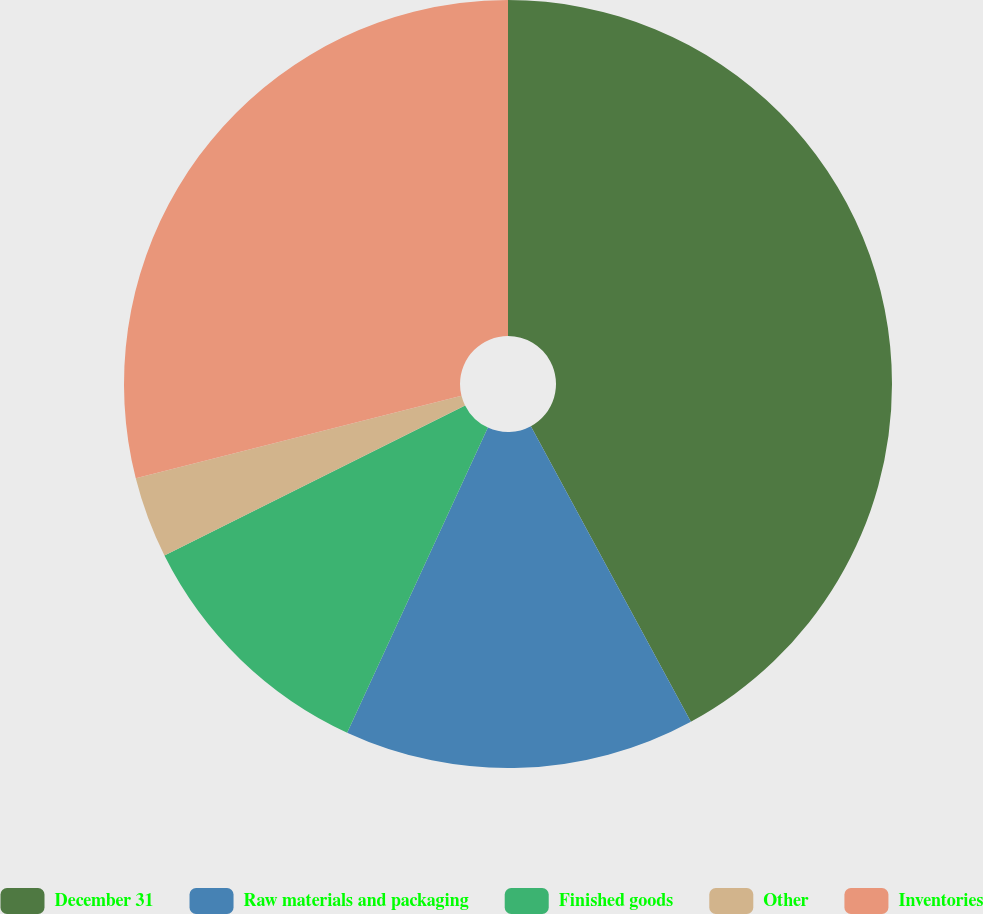Convert chart to OTSL. <chart><loc_0><loc_0><loc_500><loc_500><pie_chart><fcel>December 31<fcel>Raw materials and packaging<fcel>Finished goods<fcel>Other<fcel>Inventories<nl><fcel>42.1%<fcel>14.78%<fcel>10.75%<fcel>3.42%<fcel>28.95%<nl></chart> 